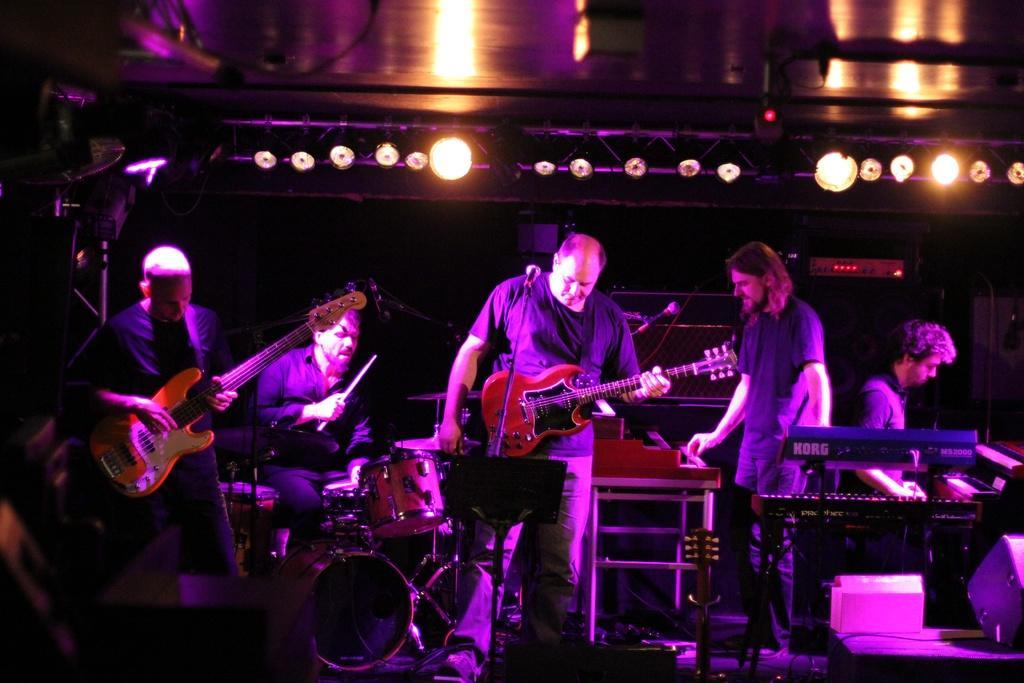In one or two sentences, can you explain what this image depicts? In the middle of the image few people are standing and playing some musical instruments. In the middle of the image there is a roof and there are some lights. 